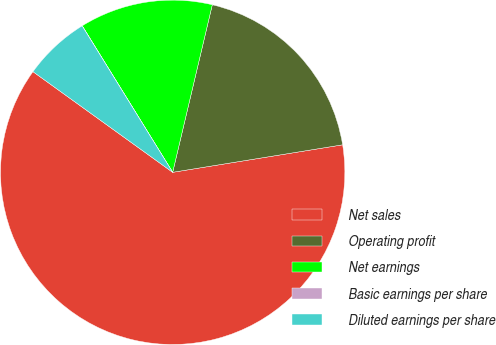Convert chart to OTSL. <chart><loc_0><loc_0><loc_500><loc_500><pie_chart><fcel>Net sales<fcel>Operating profit<fcel>Net earnings<fcel>Basic earnings per share<fcel>Diluted earnings per share<nl><fcel>62.49%<fcel>18.75%<fcel>12.5%<fcel>0.01%<fcel>6.25%<nl></chart> 